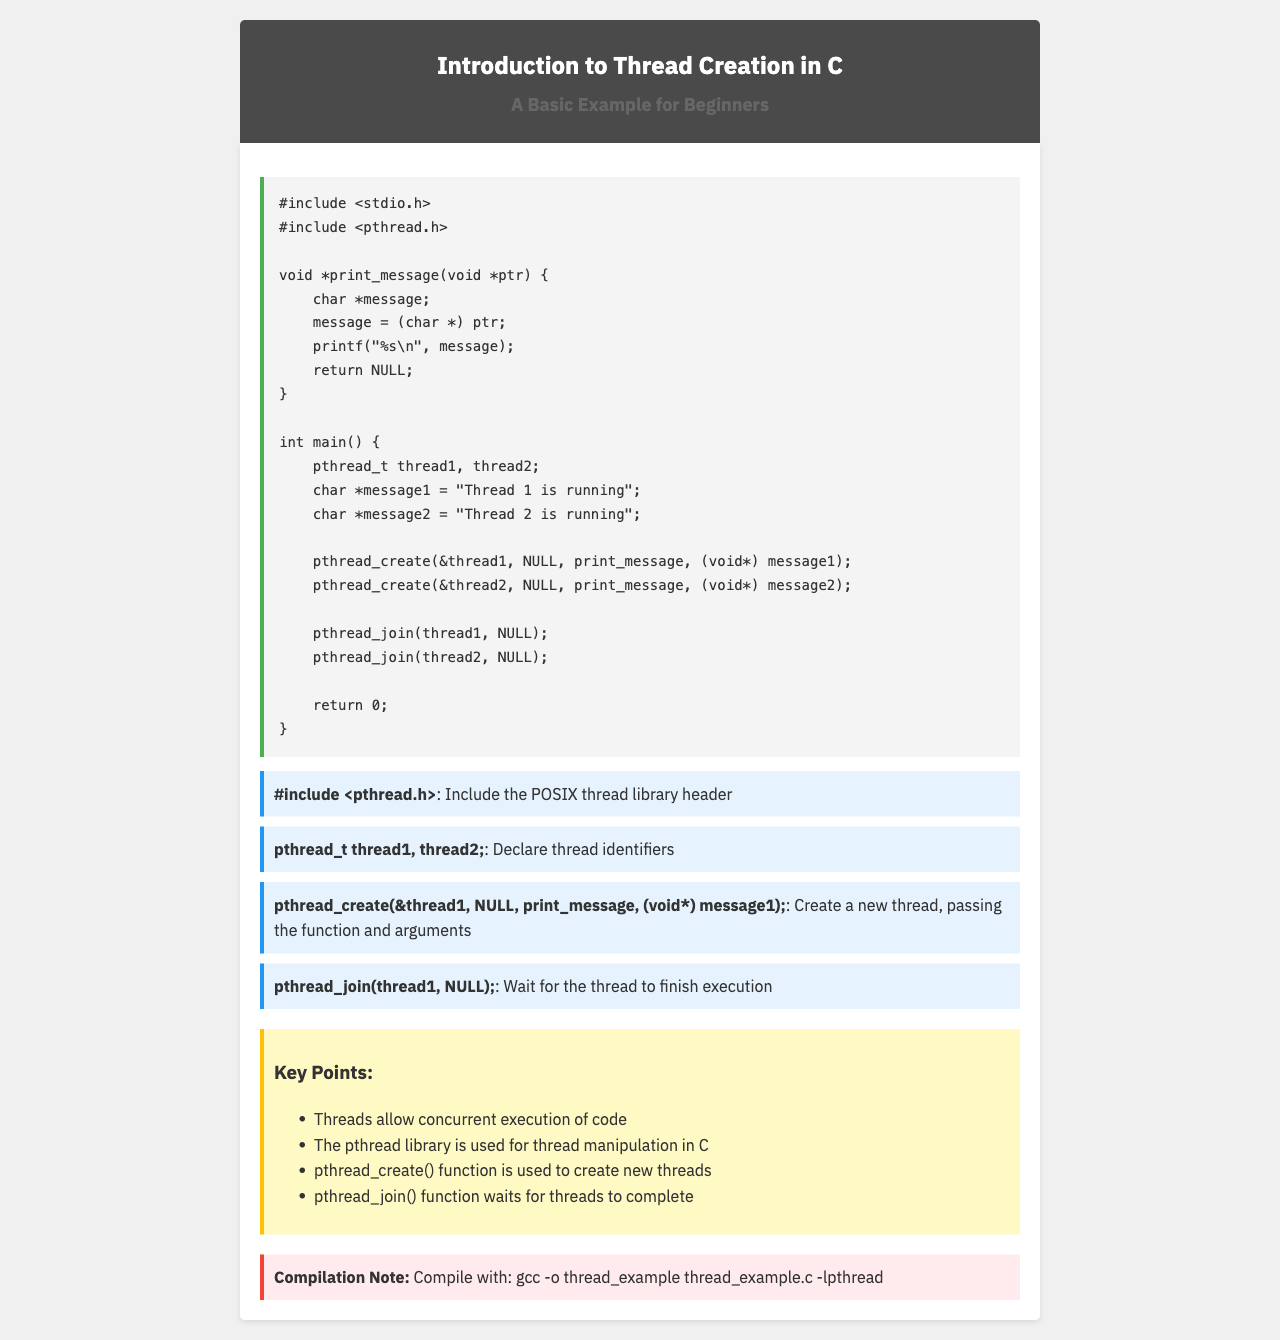what is the title of the document? The title is presented at the top of the fax, indicating the main subject of the content.
Answer: Introduction to Thread Creation in C what is the purpose of the pthread_create function? This function is described as the means to create new threads in the document.
Answer: Create new threads how many threads are declared in the code? The document mentions the declarations of two thread identifiers in the code snippet.
Answer: 2 which library is included for multithreading? The relevant library for thread manipulation is specified in the include directives.
Answer: pthread.h what command is provided for compiling the code? The document contains a specific command to compile the code including the necessary library flag.
Answer: gcc -o thread_example thread_example.c -lpthread name one key point discussed in the document. Several key points about threading are listed, highlighting important aspects of using threads.
Answer: Threads allow concurrent execution of code what do pthread_join function calls do? The document explains the role of pthread_join in relation to thread execution and completion.
Answer: Wait for the thread to finish execution what type of document is this? The structure and content are indicative of an informational fax focused on programming concepts.
Answer: Fax what color is the background of the fax content area? The background color of the content area is described in the document’s CSS styles.
Answer: White 